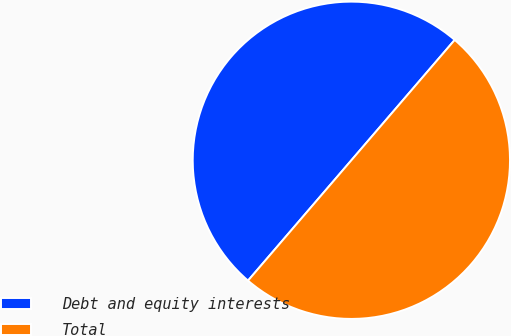Convert chart to OTSL. <chart><loc_0><loc_0><loc_500><loc_500><pie_chart><fcel>Debt and equity interests<fcel>Total<nl><fcel>50.0%<fcel>50.0%<nl></chart> 